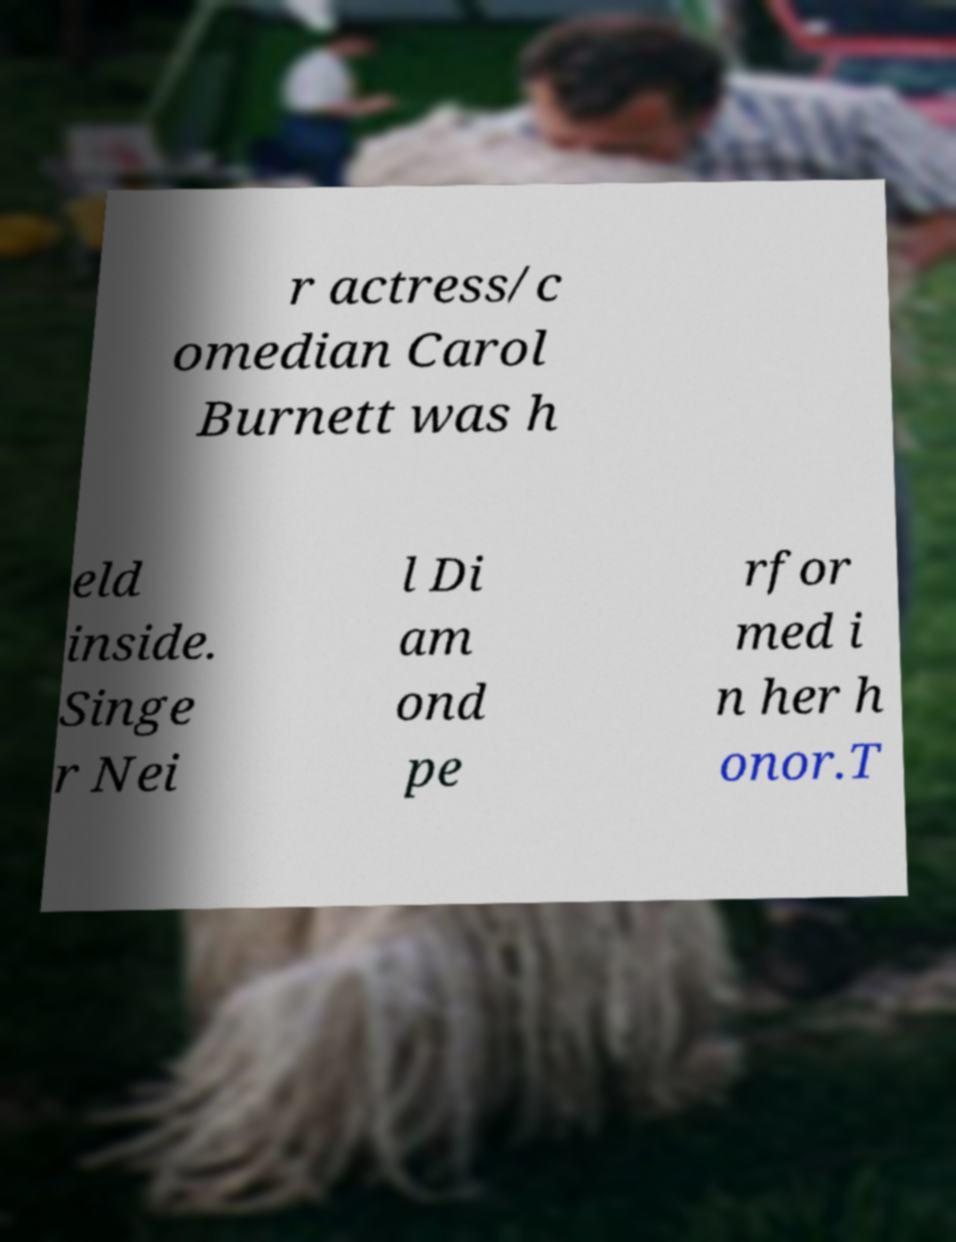Could you extract and type out the text from this image? r actress/c omedian Carol Burnett was h eld inside. Singe r Nei l Di am ond pe rfor med i n her h onor.T 